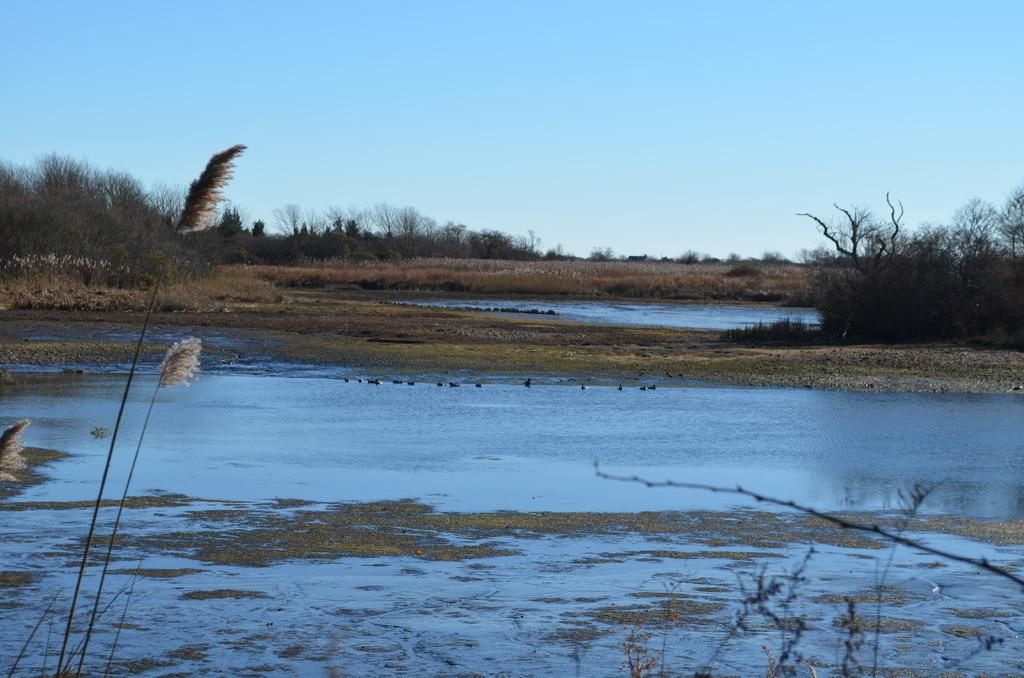What is the primary element visible in the image? There is water in the image. What type of vegetation can be seen on the surface in the image? Grass is present on the surface in the image. What can be seen in the background of the image? There are trees and the sky visible in the background of the image. What type of patch is visible on the jeans in the image? There are no jeans or patches present in the image; it features water, grass, trees, and the sky. 